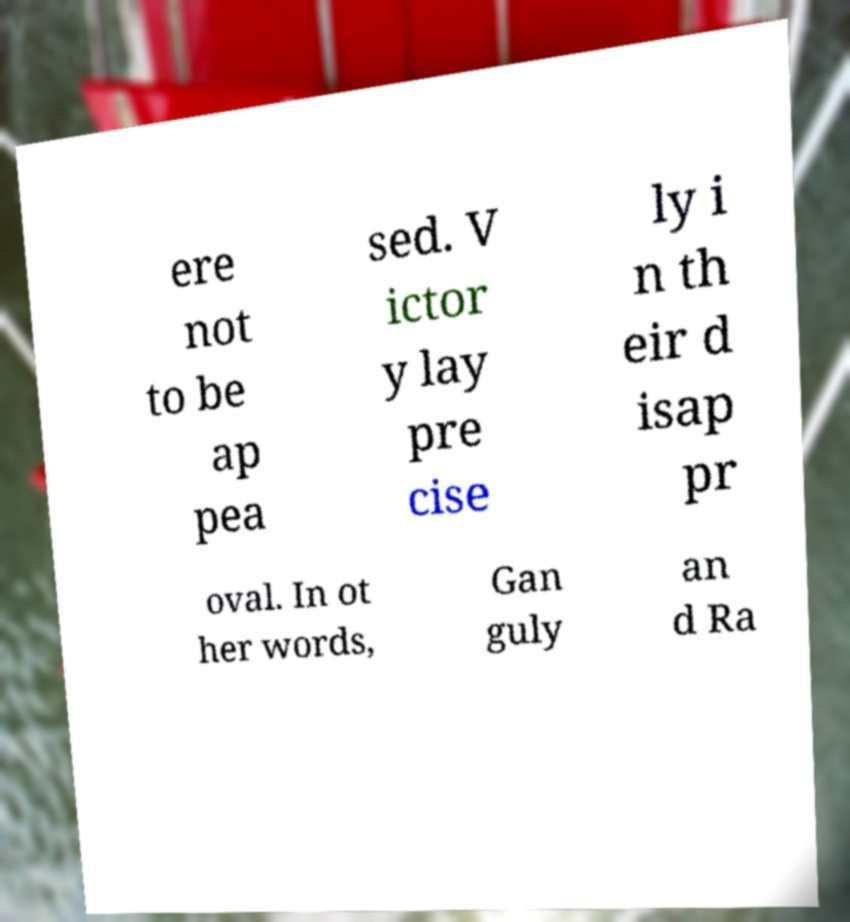I need the written content from this picture converted into text. Can you do that? ere not to be ap pea sed. V ictor y lay pre cise ly i n th eir d isap pr oval. In ot her words, Gan guly an d Ra 